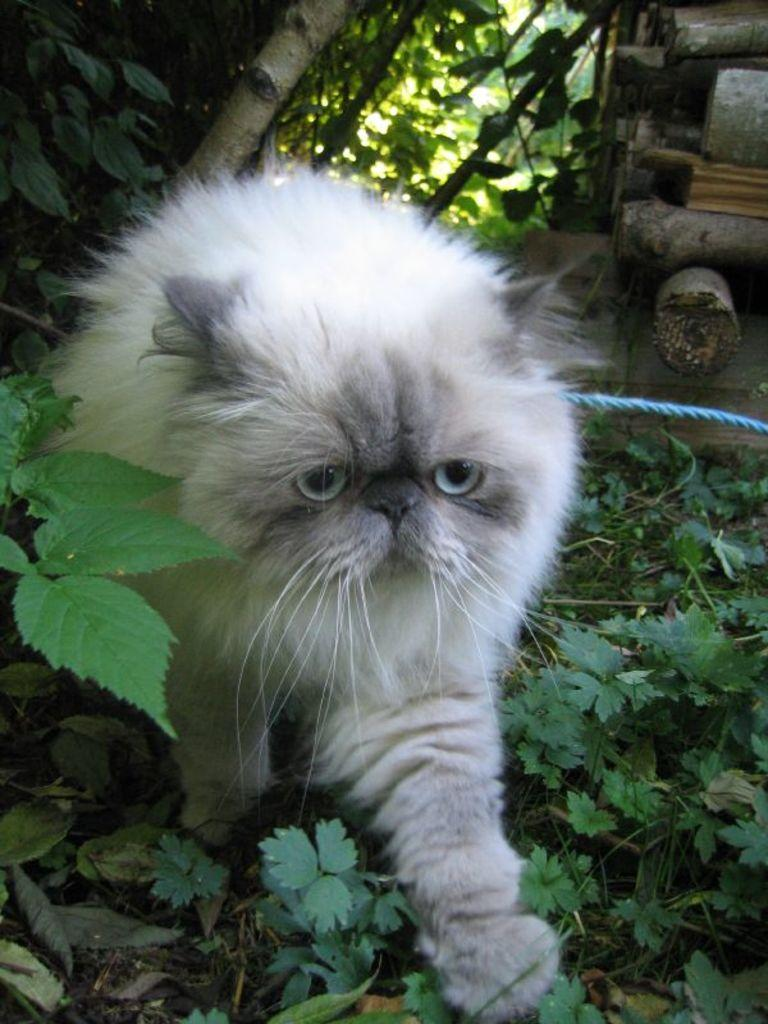What type of animal is in the image? There is a cat in the image. Can you describe the appearance of the cat? The cat is white and black in color. What natural elements can be seen in the image? Tree barks, trees, and plants on the ground are visible in the image. What type of camp can be seen in the image? There is no camp present in the image; it features a cat and natural elements. What feeling does the image evoke in the viewer? The image does not evoke a specific feeling, as it is a static representation of a cat and natural elements. 